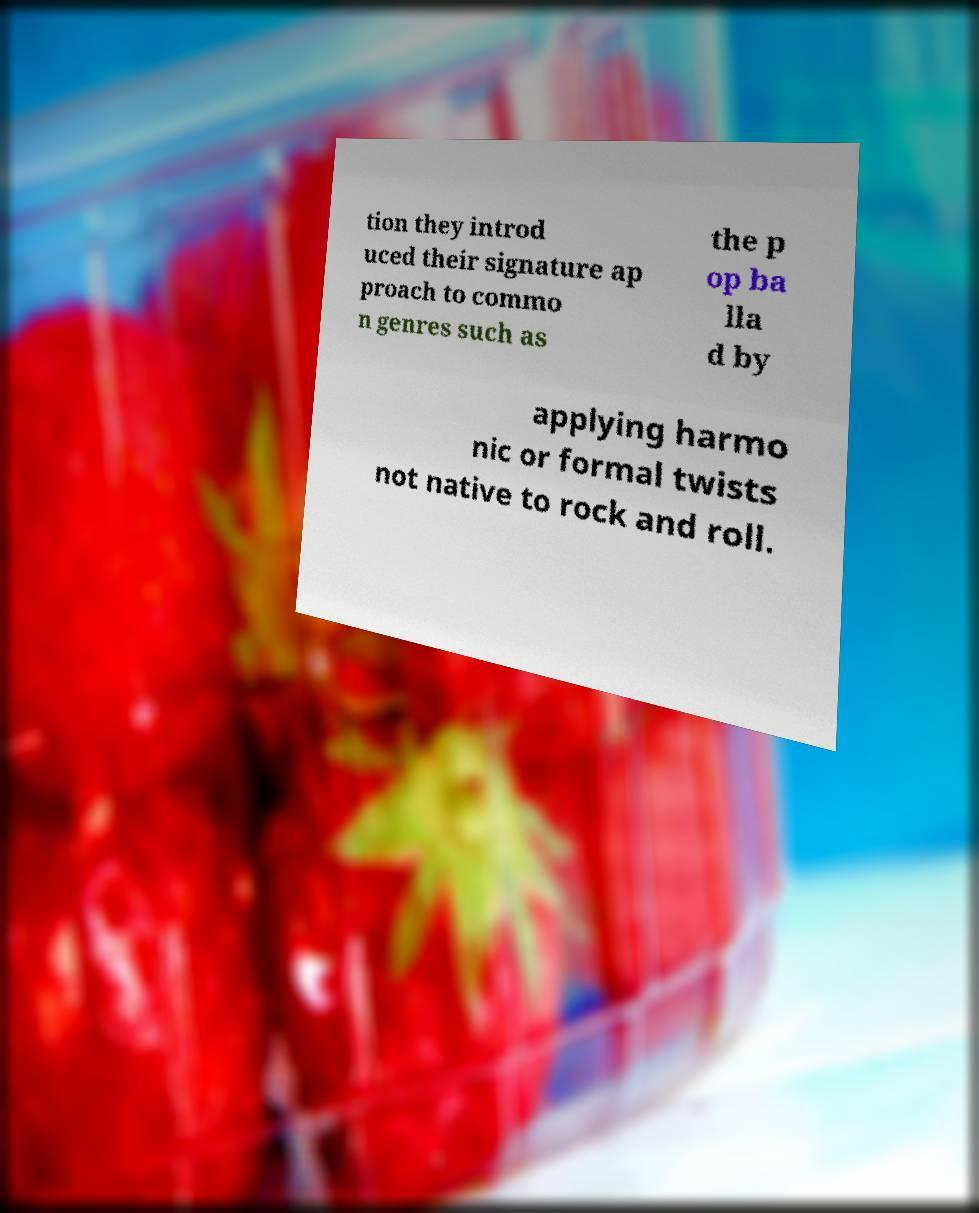There's text embedded in this image that I need extracted. Can you transcribe it verbatim? tion they introd uced their signature ap proach to commo n genres such as the p op ba lla d by applying harmo nic or formal twists not native to rock and roll. 